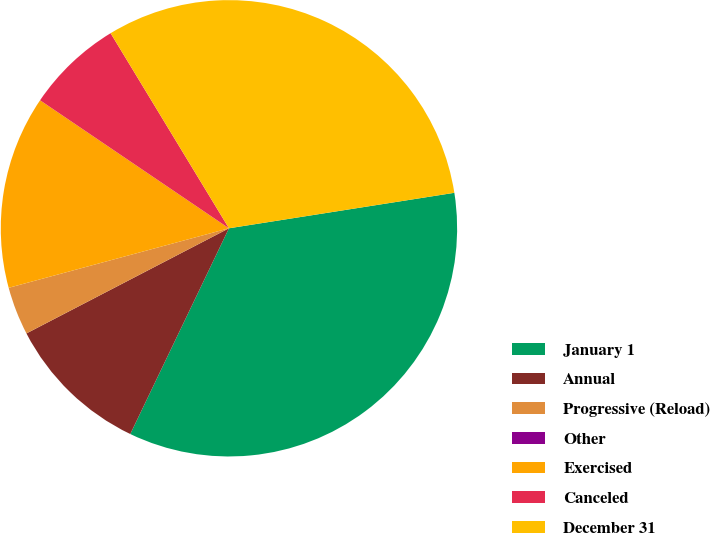Convert chart to OTSL. <chart><loc_0><loc_0><loc_500><loc_500><pie_chart><fcel>January 1<fcel>Annual<fcel>Progressive (Reload)<fcel>Other<fcel>Exercised<fcel>Canceled<fcel>December 31<nl><fcel>34.6%<fcel>10.26%<fcel>3.42%<fcel>0.0%<fcel>13.68%<fcel>6.84%<fcel>31.19%<nl></chart> 